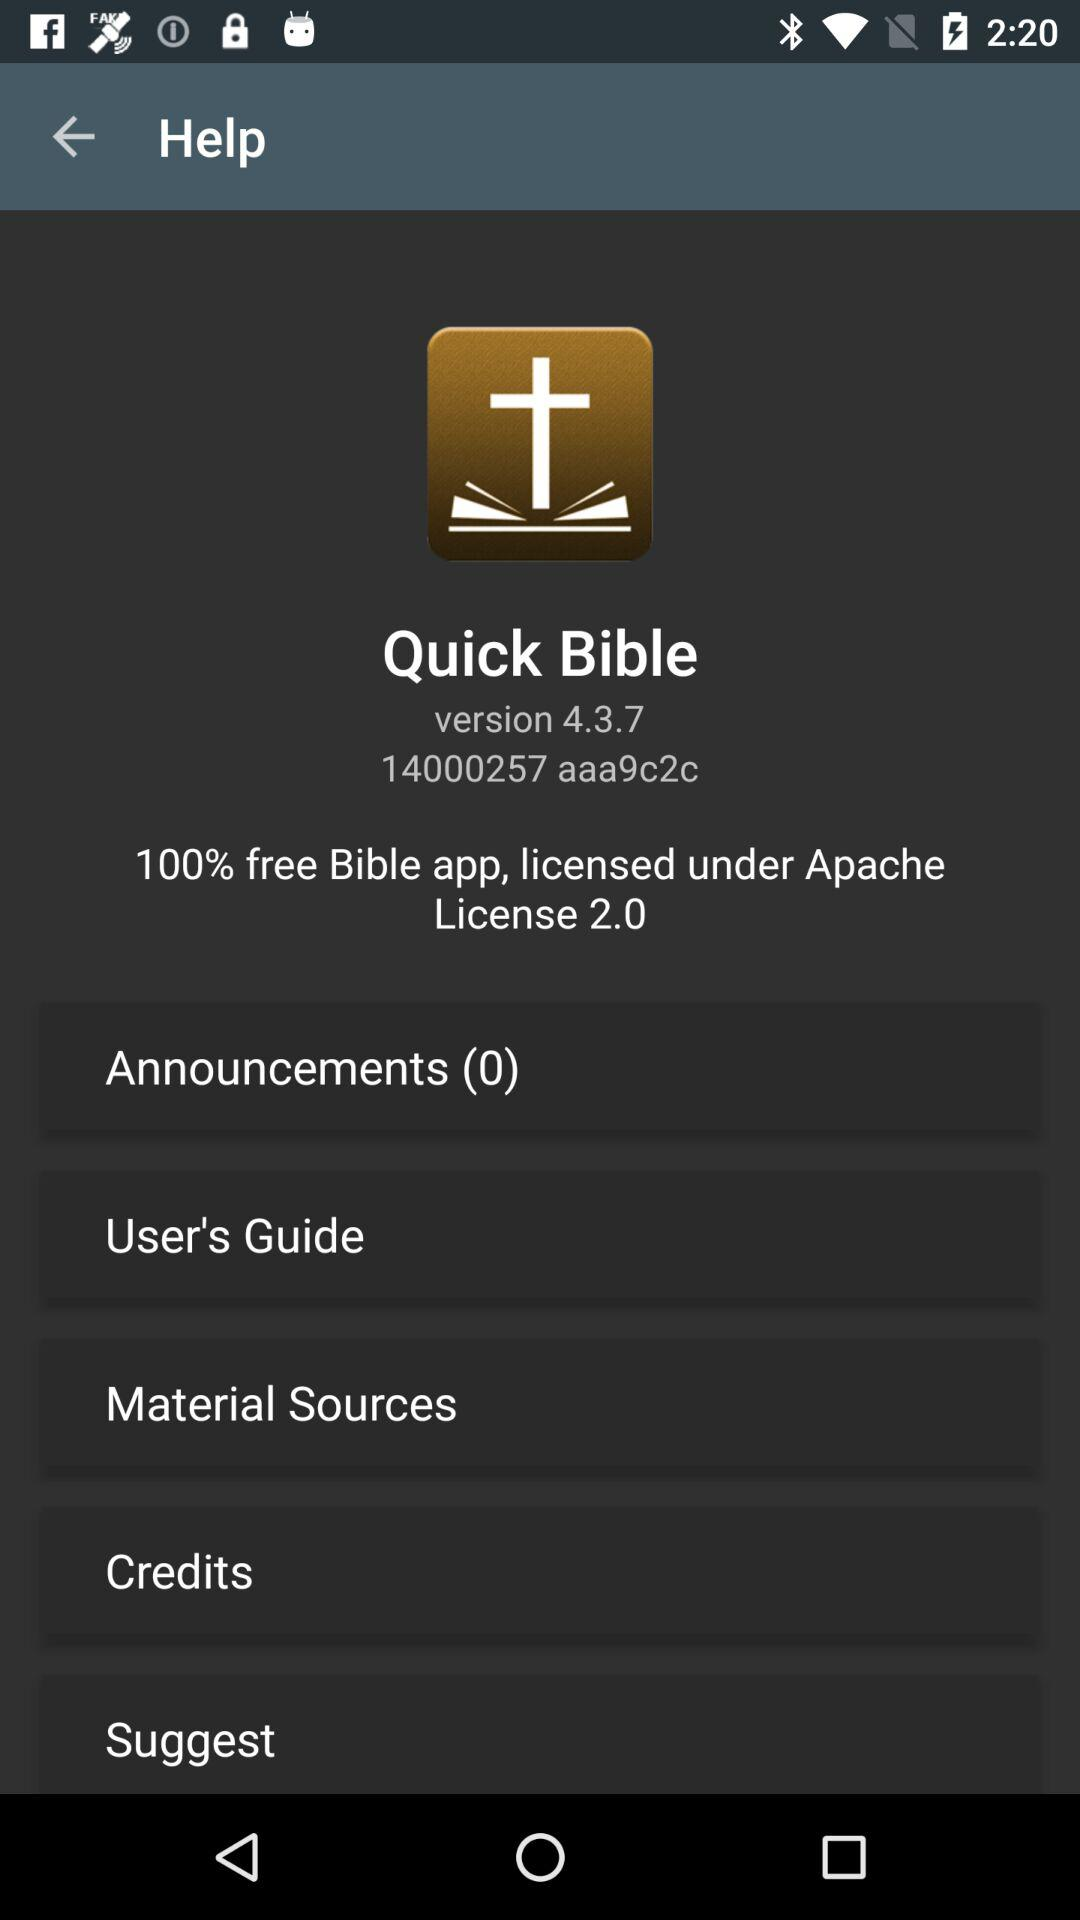How many announcements are there? There are 0 announcements. 